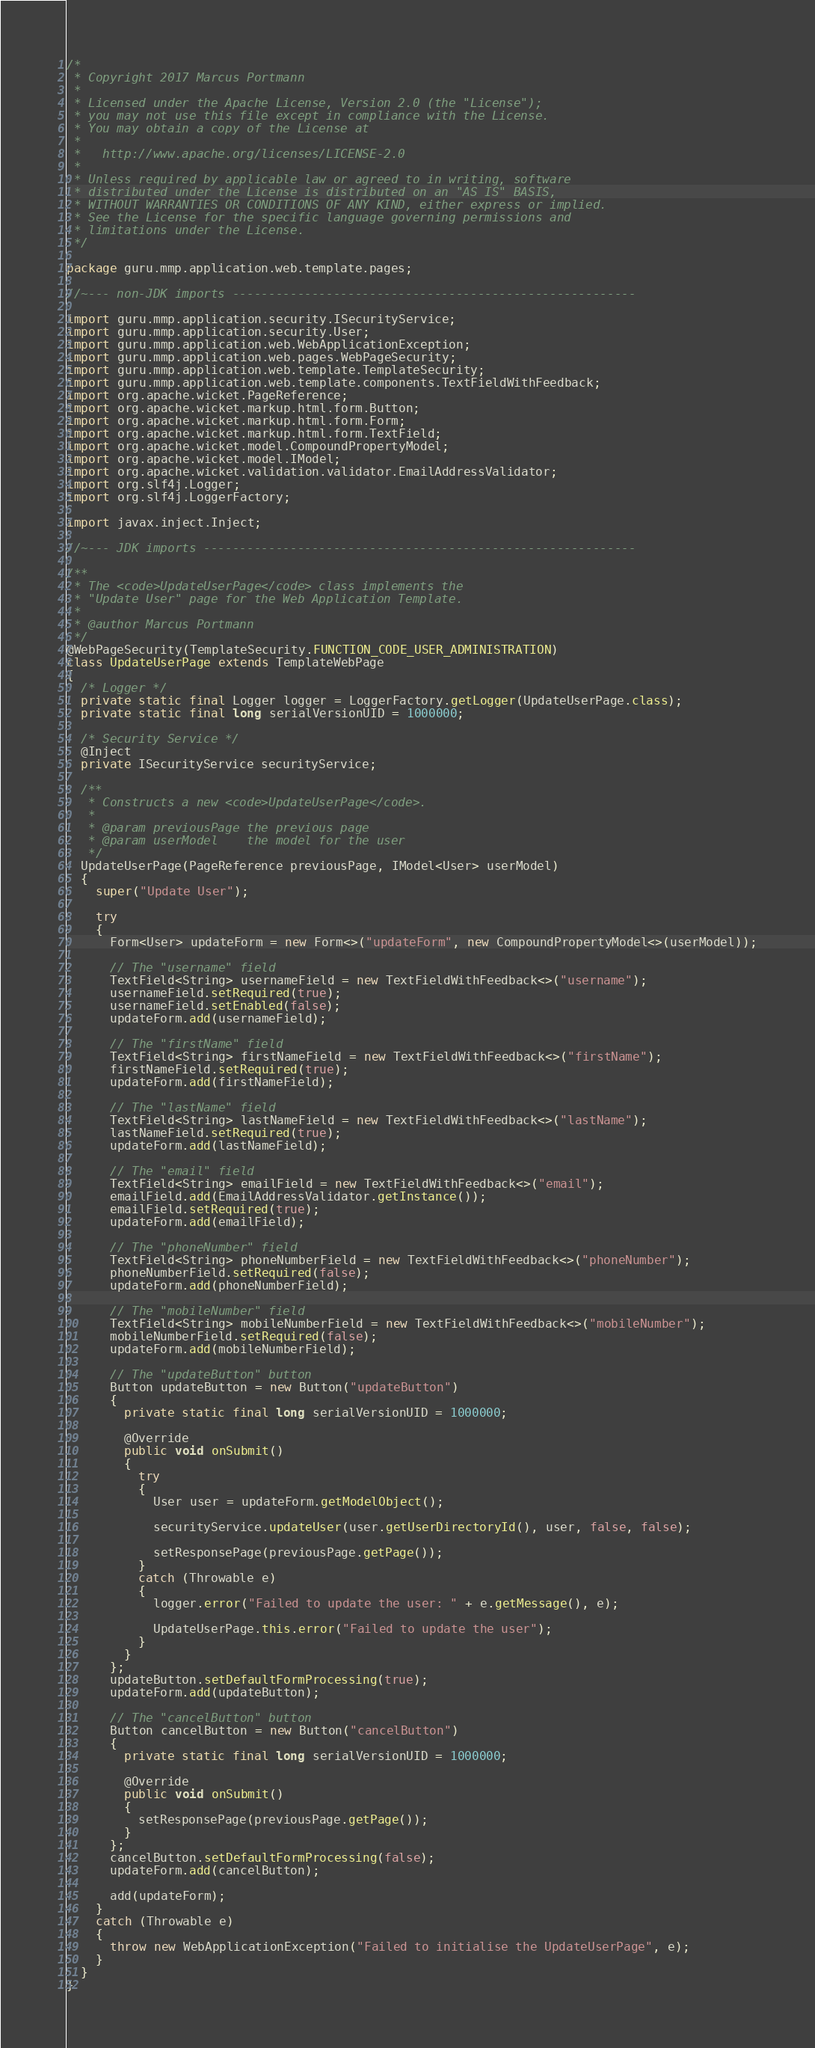Convert code to text. <code><loc_0><loc_0><loc_500><loc_500><_Java_>/*
 * Copyright 2017 Marcus Portmann
 *
 * Licensed under the Apache License, Version 2.0 (the "License");
 * you may not use this file except in compliance with the License.
 * You may obtain a copy of the License at
 *
 *   http://www.apache.org/licenses/LICENSE-2.0
 *
 * Unless required by applicable law or agreed to in writing, software
 * distributed under the License is distributed on an "AS IS" BASIS,
 * WITHOUT WARRANTIES OR CONDITIONS OF ANY KIND, either express or implied.
 * See the License for the specific language governing permissions and
 * limitations under the License.
 */

package guru.mmp.application.web.template.pages;

//~--- non-JDK imports --------------------------------------------------------

import guru.mmp.application.security.ISecurityService;
import guru.mmp.application.security.User;
import guru.mmp.application.web.WebApplicationException;
import guru.mmp.application.web.pages.WebPageSecurity;
import guru.mmp.application.web.template.TemplateSecurity;
import guru.mmp.application.web.template.components.TextFieldWithFeedback;
import org.apache.wicket.PageReference;
import org.apache.wicket.markup.html.form.Button;
import org.apache.wicket.markup.html.form.Form;
import org.apache.wicket.markup.html.form.TextField;
import org.apache.wicket.model.CompoundPropertyModel;
import org.apache.wicket.model.IModel;
import org.apache.wicket.validation.validator.EmailAddressValidator;
import org.slf4j.Logger;
import org.slf4j.LoggerFactory;

import javax.inject.Inject;

//~--- JDK imports ------------------------------------------------------------

/**
 * The <code>UpdateUserPage</code> class implements the
 * "Update User" page for the Web Application Template.
 *
 * @author Marcus Portmann
 */
@WebPageSecurity(TemplateSecurity.FUNCTION_CODE_USER_ADMINISTRATION)
class UpdateUserPage extends TemplateWebPage
{
  /* Logger */
  private static final Logger logger = LoggerFactory.getLogger(UpdateUserPage.class);
  private static final long serialVersionUID = 1000000;

  /* Security Service */
  @Inject
  private ISecurityService securityService;

  /**
   * Constructs a new <code>UpdateUserPage</code>.
   *
   * @param previousPage the previous page
   * @param userModel    the model for the user
   */
  UpdateUserPage(PageReference previousPage, IModel<User> userModel)
  {
    super("Update User");

    try
    {
      Form<User> updateForm = new Form<>("updateForm", new CompoundPropertyModel<>(userModel));

      // The "username" field
      TextField<String> usernameField = new TextFieldWithFeedback<>("username");
      usernameField.setRequired(true);
      usernameField.setEnabled(false);
      updateForm.add(usernameField);

      // The "firstName" field
      TextField<String> firstNameField = new TextFieldWithFeedback<>("firstName");
      firstNameField.setRequired(true);
      updateForm.add(firstNameField);

      // The "lastName" field
      TextField<String> lastNameField = new TextFieldWithFeedback<>("lastName");
      lastNameField.setRequired(true);
      updateForm.add(lastNameField);

      // The "email" field
      TextField<String> emailField = new TextFieldWithFeedback<>("email");
      emailField.add(EmailAddressValidator.getInstance());
      emailField.setRequired(true);
      updateForm.add(emailField);

      // The "phoneNumber" field
      TextField<String> phoneNumberField = new TextFieldWithFeedback<>("phoneNumber");
      phoneNumberField.setRequired(false);
      updateForm.add(phoneNumberField);

      // The "mobileNumber" field
      TextField<String> mobileNumberField = new TextFieldWithFeedback<>("mobileNumber");
      mobileNumberField.setRequired(false);
      updateForm.add(mobileNumberField);

      // The "updateButton" button
      Button updateButton = new Button("updateButton")
      {
        private static final long serialVersionUID = 1000000;

        @Override
        public void onSubmit()
        {
          try
          {
            User user = updateForm.getModelObject();

            securityService.updateUser(user.getUserDirectoryId(), user, false, false);

            setResponsePage(previousPage.getPage());
          }
          catch (Throwable e)
          {
            logger.error("Failed to update the user: " + e.getMessage(), e);

            UpdateUserPage.this.error("Failed to update the user");
          }
        }
      };
      updateButton.setDefaultFormProcessing(true);
      updateForm.add(updateButton);

      // The "cancelButton" button
      Button cancelButton = new Button("cancelButton")
      {
        private static final long serialVersionUID = 1000000;

        @Override
        public void onSubmit()
        {
          setResponsePage(previousPage.getPage());
        }
      };
      cancelButton.setDefaultFormProcessing(false);
      updateForm.add(cancelButton);

      add(updateForm);
    }
    catch (Throwable e)
    {
      throw new WebApplicationException("Failed to initialise the UpdateUserPage", e);
    }
  }
}
</code> 